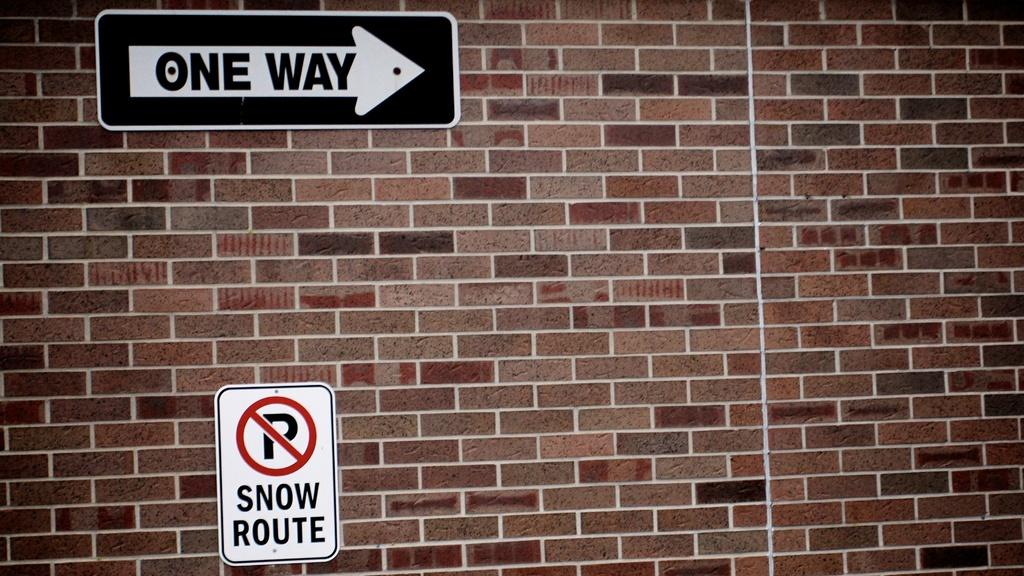<image>
Write a terse but informative summary of the picture. A brick wall with a one way sign on it and a no parking snow route sign on it as well. 